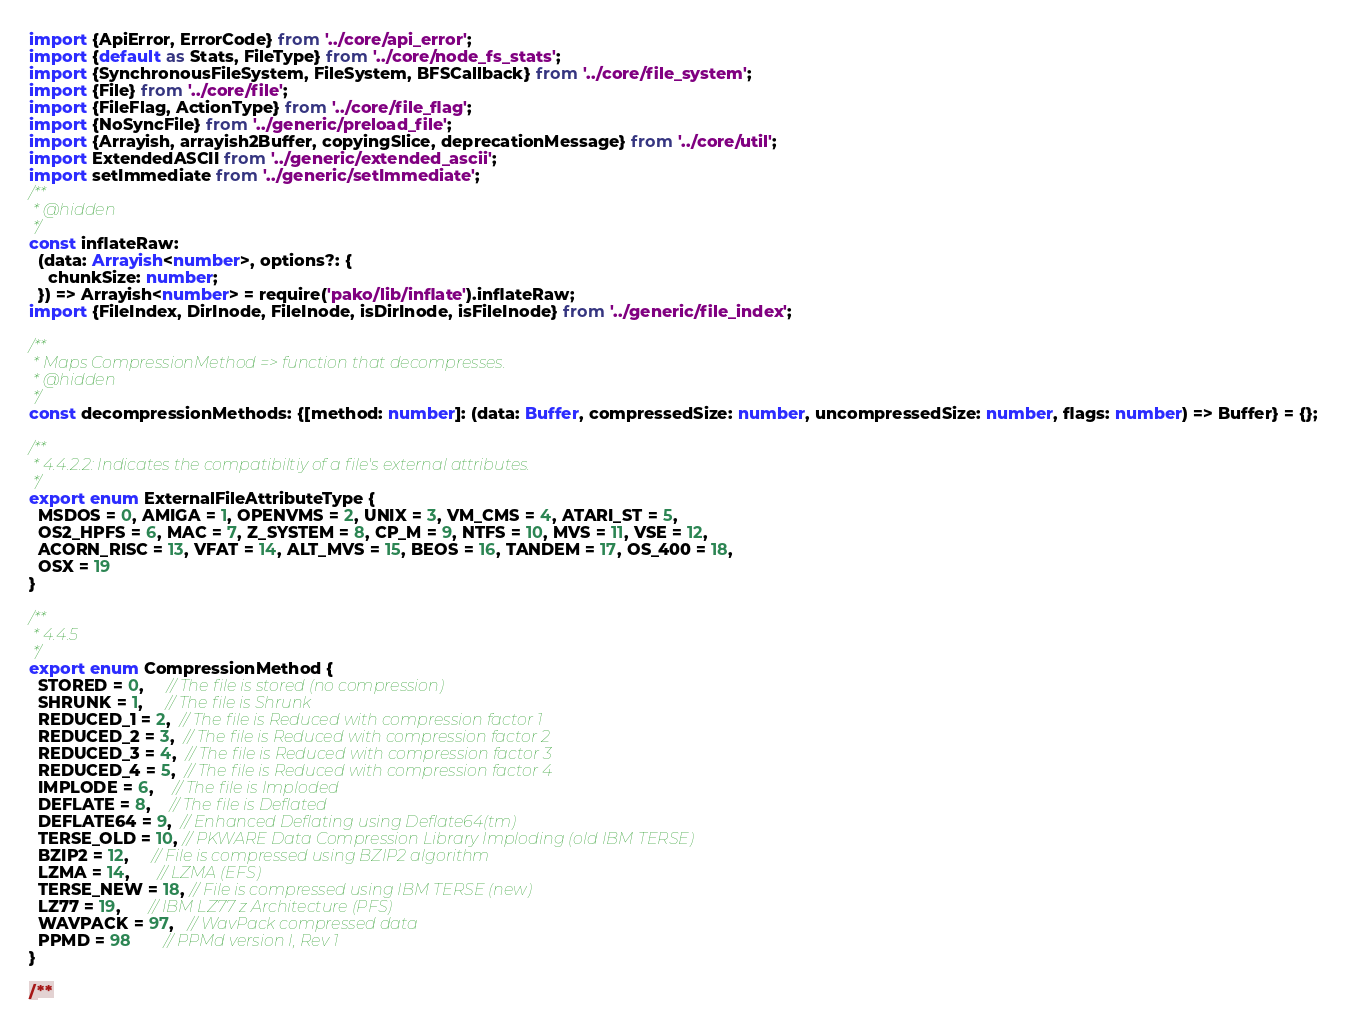<code> <loc_0><loc_0><loc_500><loc_500><_TypeScript_>import {ApiError, ErrorCode} from '../core/api_error';
import {default as Stats, FileType} from '../core/node_fs_stats';
import {SynchronousFileSystem, FileSystem, BFSCallback} from '../core/file_system';
import {File} from '../core/file';
import {FileFlag, ActionType} from '../core/file_flag';
import {NoSyncFile} from '../generic/preload_file';
import {Arrayish, arrayish2Buffer, copyingSlice, deprecationMessage} from '../core/util';
import ExtendedASCII from '../generic/extended_ascii';
import setImmediate from '../generic/setImmediate';
/**
 * @hidden
 */
const inflateRaw:
  (data: Arrayish<number>, options?: {
    chunkSize: number;
  }) => Arrayish<number> = require('pako/lib/inflate').inflateRaw;
import {FileIndex, DirInode, FileInode, isDirInode, isFileInode} from '../generic/file_index';

/**
 * Maps CompressionMethod => function that decompresses.
 * @hidden
 */
const decompressionMethods: {[method: number]: (data: Buffer, compressedSize: number, uncompressedSize: number, flags: number) => Buffer} = {};

/**
 * 4.4.2.2: Indicates the compatibiltiy of a file's external attributes.
 */
export enum ExternalFileAttributeType {
  MSDOS = 0, AMIGA = 1, OPENVMS = 2, UNIX = 3, VM_CMS = 4, ATARI_ST = 5,
  OS2_HPFS = 6, MAC = 7, Z_SYSTEM = 8, CP_M = 9, NTFS = 10, MVS = 11, VSE = 12,
  ACORN_RISC = 13, VFAT = 14, ALT_MVS = 15, BEOS = 16, TANDEM = 17, OS_400 = 18,
  OSX = 19
}

/**
 * 4.4.5
 */
export enum CompressionMethod {
  STORED = 0,     // The file is stored (no compression)
  SHRUNK = 1,     // The file is Shrunk
  REDUCED_1 = 2,  // The file is Reduced with compression factor 1
  REDUCED_2 = 3,  // The file is Reduced with compression factor 2
  REDUCED_3 = 4,  // The file is Reduced with compression factor 3
  REDUCED_4 = 5,  // The file is Reduced with compression factor 4
  IMPLODE = 6,    // The file is Imploded
  DEFLATE = 8,    // The file is Deflated
  DEFLATE64 = 9,  // Enhanced Deflating using Deflate64(tm)
  TERSE_OLD = 10, // PKWARE Data Compression Library Imploding (old IBM TERSE)
  BZIP2 = 12,     // File is compressed using BZIP2 algorithm
  LZMA = 14,      // LZMA (EFS)
  TERSE_NEW = 18, // File is compressed using IBM TERSE (new)
  LZ77 = 19,      // IBM LZ77 z Architecture (PFS)
  WAVPACK = 97,   // WavPack compressed data
  PPMD = 98       // PPMd version I, Rev 1
}

/**</code> 